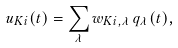<formula> <loc_0><loc_0><loc_500><loc_500>u _ { K i } ( t ) = \sum _ { \lambda } w _ { K i , \lambda } \, q _ { \lambda } ( t ) ,</formula> 